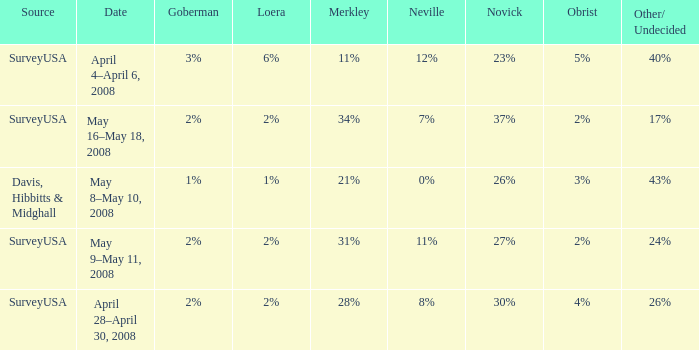Which Novick has a Source of surveyusa, and a Neville of 8%? 30%. 